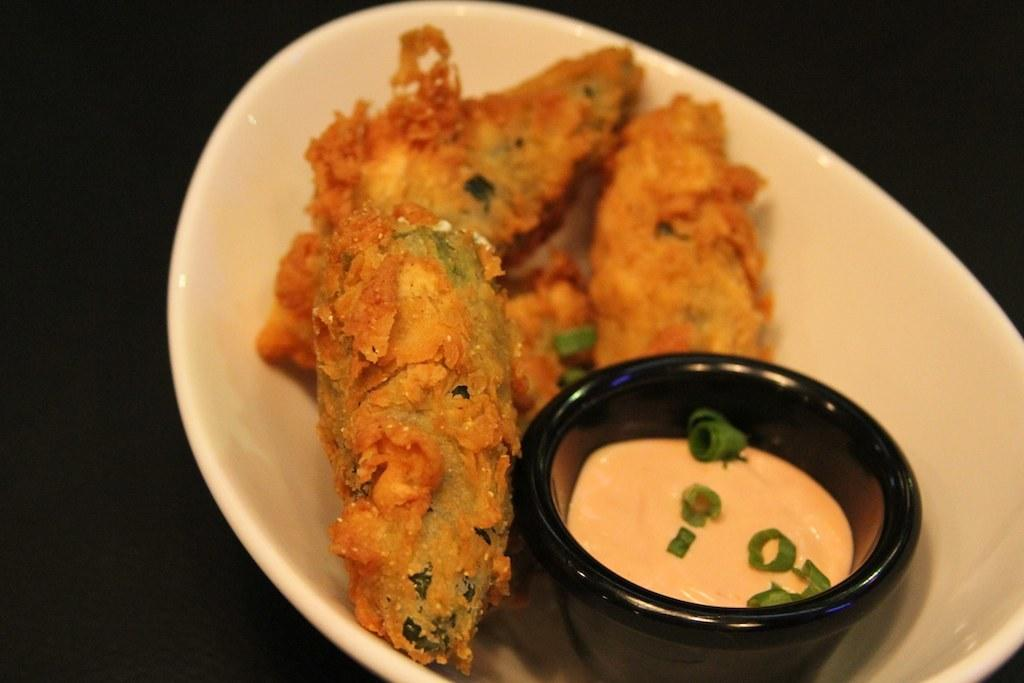What is in the bowls that are visible in the image? There is food in the bowls in the image. What can be observed about the lighting or color scheme of the image? The background of the image is dark. What type of crook can be seen in the image? There is no crook present in the image. What kind of rock is visible in the image? There is no rock present in the image. 